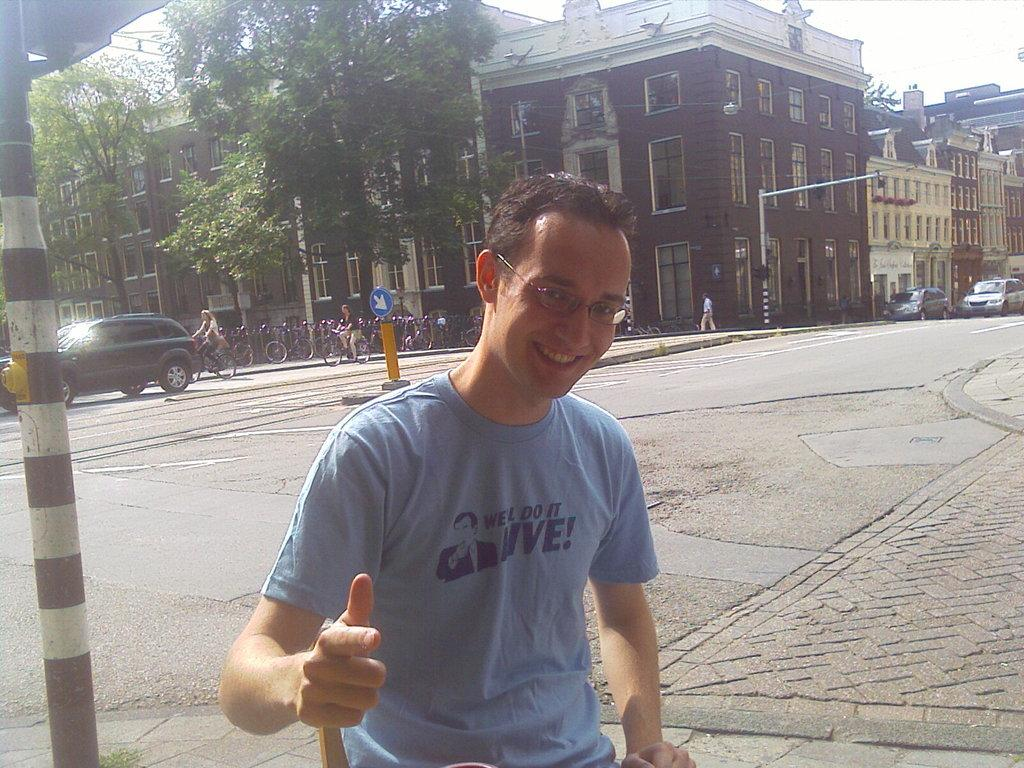What can be seen in the image? There is a person in the image. Can you describe the person's appearance? The person is wearing spectacles and smiling. What is visible in the background of the image? There are buildings with windows, trees, bicycles, and a car in the background of the image. What type of loaf is being carried by the donkey in the image? There is no donkey or loaf present in the image. 